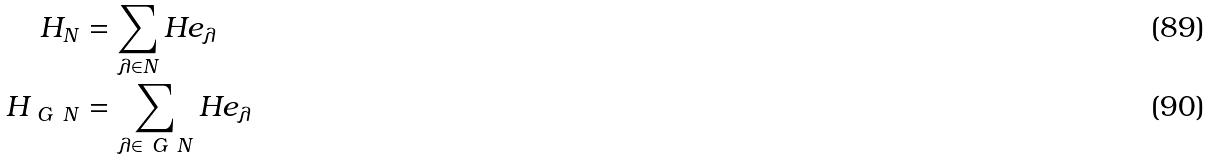<formula> <loc_0><loc_0><loc_500><loc_500>H _ { N } & = \sum _ { \lambda \in N } H e _ { \lambda } \\ H _ { \ G \ N } & = \sum _ { \lambda \in \ G \ N } H e _ { \lambda }</formula> 